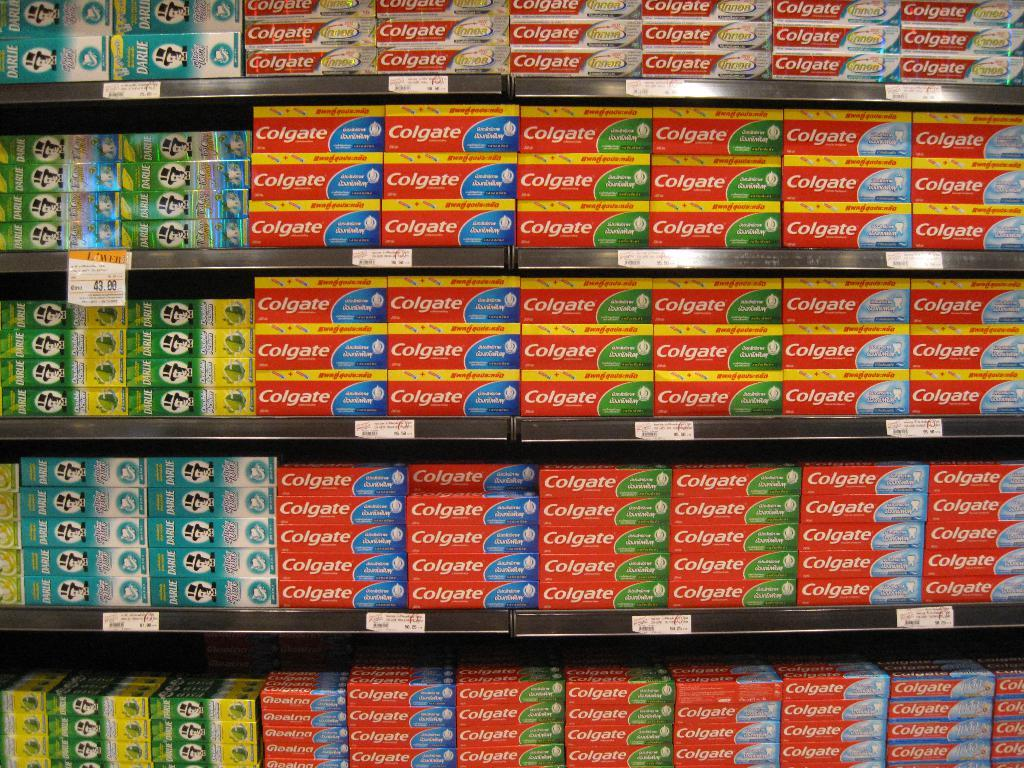<image>
Present a compact description of the photo's key features. a display of colgate toothpastes filling at least 5 store shelves 